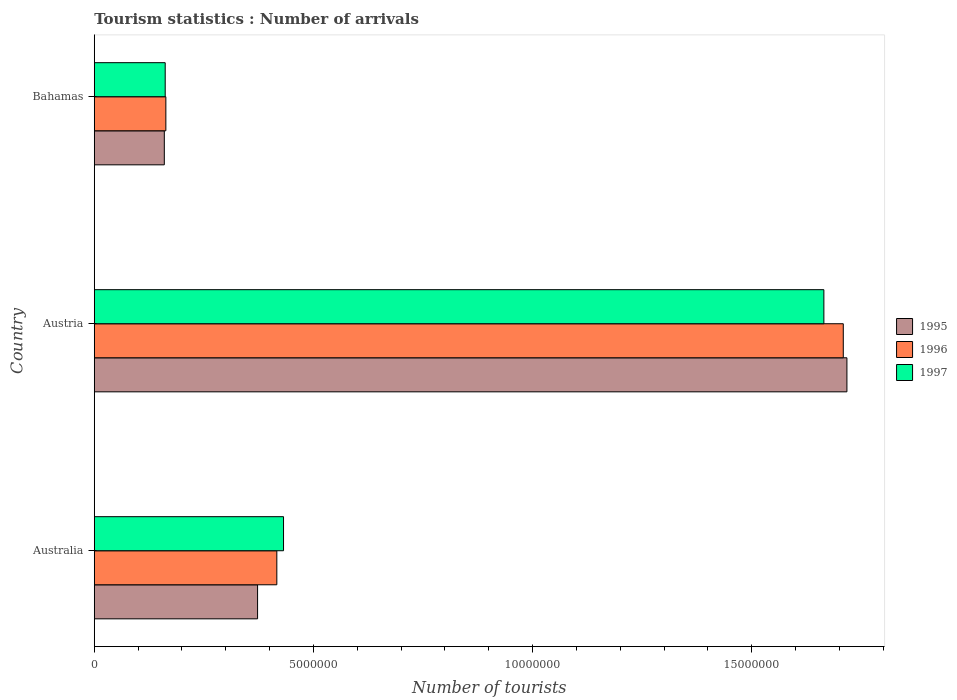Are the number of bars per tick equal to the number of legend labels?
Your answer should be very brief. Yes. Are the number of bars on each tick of the Y-axis equal?
Provide a short and direct response. Yes. How many bars are there on the 1st tick from the top?
Give a very brief answer. 3. How many bars are there on the 3rd tick from the bottom?
Keep it short and to the point. 3. In how many cases, is the number of bars for a given country not equal to the number of legend labels?
Provide a short and direct response. 0. What is the number of tourist arrivals in 1995 in Bahamas?
Your answer should be very brief. 1.60e+06. Across all countries, what is the maximum number of tourist arrivals in 1996?
Make the answer very short. 1.71e+07. Across all countries, what is the minimum number of tourist arrivals in 1995?
Your answer should be compact. 1.60e+06. In which country was the number of tourist arrivals in 1997 maximum?
Your answer should be very brief. Austria. In which country was the number of tourist arrivals in 1996 minimum?
Your response must be concise. Bahamas. What is the total number of tourist arrivals in 1996 in the graph?
Keep it short and to the point. 2.29e+07. What is the difference between the number of tourist arrivals in 1997 in Australia and that in Austria?
Keep it short and to the point. -1.23e+07. What is the difference between the number of tourist arrivals in 1996 in Bahamas and the number of tourist arrivals in 1995 in Australia?
Offer a very short reply. -2.09e+06. What is the average number of tourist arrivals in 1995 per country?
Offer a very short reply. 7.50e+06. What is the difference between the number of tourist arrivals in 1997 and number of tourist arrivals in 1996 in Australia?
Provide a succinct answer. 1.53e+05. What is the ratio of the number of tourist arrivals in 1996 in Austria to that in Bahamas?
Offer a terse response. 10.47. Is the number of tourist arrivals in 1995 in Australia less than that in Austria?
Your answer should be very brief. Yes. Is the difference between the number of tourist arrivals in 1997 in Australia and Austria greater than the difference between the number of tourist arrivals in 1996 in Australia and Austria?
Provide a succinct answer. Yes. What is the difference between the highest and the second highest number of tourist arrivals in 1997?
Your response must be concise. 1.23e+07. What is the difference between the highest and the lowest number of tourist arrivals in 1996?
Provide a short and direct response. 1.55e+07. In how many countries, is the number of tourist arrivals in 1995 greater than the average number of tourist arrivals in 1995 taken over all countries?
Give a very brief answer. 1. Is the sum of the number of tourist arrivals in 1995 in Australia and Austria greater than the maximum number of tourist arrivals in 1996 across all countries?
Offer a very short reply. Yes. Is it the case that in every country, the sum of the number of tourist arrivals in 1995 and number of tourist arrivals in 1997 is greater than the number of tourist arrivals in 1996?
Ensure brevity in your answer.  Yes. How many bars are there?
Give a very brief answer. 9. What is the difference between two consecutive major ticks on the X-axis?
Keep it short and to the point. 5.00e+06. Does the graph contain grids?
Keep it short and to the point. No. How many legend labels are there?
Your response must be concise. 3. What is the title of the graph?
Ensure brevity in your answer.  Tourism statistics : Number of arrivals. Does "1967" appear as one of the legend labels in the graph?
Make the answer very short. No. What is the label or title of the X-axis?
Your answer should be very brief. Number of tourists. What is the label or title of the Y-axis?
Offer a terse response. Country. What is the Number of tourists in 1995 in Australia?
Keep it short and to the point. 3.73e+06. What is the Number of tourists of 1996 in Australia?
Keep it short and to the point. 4.16e+06. What is the Number of tourists in 1997 in Australia?
Ensure brevity in your answer.  4.32e+06. What is the Number of tourists of 1995 in Austria?
Make the answer very short. 1.72e+07. What is the Number of tourists in 1996 in Austria?
Make the answer very short. 1.71e+07. What is the Number of tourists in 1997 in Austria?
Offer a terse response. 1.66e+07. What is the Number of tourists in 1995 in Bahamas?
Your answer should be very brief. 1.60e+06. What is the Number of tourists in 1996 in Bahamas?
Offer a very short reply. 1.63e+06. What is the Number of tourists of 1997 in Bahamas?
Your response must be concise. 1.62e+06. Across all countries, what is the maximum Number of tourists of 1995?
Give a very brief answer. 1.72e+07. Across all countries, what is the maximum Number of tourists of 1996?
Provide a short and direct response. 1.71e+07. Across all countries, what is the maximum Number of tourists of 1997?
Keep it short and to the point. 1.66e+07. Across all countries, what is the minimum Number of tourists of 1995?
Keep it short and to the point. 1.60e+06. Across all countries, what is the minimum Number of tourists of 1996?
Ensure brevity in your answer.  1.63e+06. Across all countries, what is the minimum Number of tourists of 1997?
Ensure brevity in your answer.  1.62e+06. What is the total Number of tourists of 1995 in the graph?
Provide a succinct answer. 2.25e+07. What is the total Number of tourists of 1996 in the graph?
Provide a short and direct response. 2.29e+07. What is the total Number of tourists in 1997 in the graph?
Provide a short and direct response. 2.26e+07. What is the difference between the Number of tourists of 1995 in Australia and that in Austria?
Offer a terse response. -1.34e+07. What is the difference between the Number of tourists of 1996 in Australia and that in Austria?
Your answer should be very brief. -1.29e+07. What is the difference between the Number of tourists in 1997 in Australia and that in Austria?
Ensure brevity in your answer.  -1.23e+07. What is the difference between the Number of tourists in 1995 in Australia and that in Bahamas?
Your answer should be very brief. 2.13e+06. What is the difference between the Number of tourists in 1996 in Australia and that in Bahamas?
Offer a very short reply. 2.53e+06. What is the difference between the Number of tourists of 1997 in Australia and that in Bahamas?
Ensure brevity in your answer.  2.70e+06. What is the difference between the Number of tourists in 1995 in Austria and that in Bahamas?
Give a very brief answer. 1.56e+07. What is the difference between the Number of tourists of 1996 in Austria and that in Bahamas?
Keep it short and to the point. 1.55e+07. What is the difference between the Number of tourists of 1997 in Austria and that in Bahamas?
Your answer should be very brief. 1.50e+07. What is the difference between the Number of tourists in 1995 in Australia and the Number of tourists in 1996 in Austria?
Offer a very short reply. -1.34e+07. What is the difference between the Number of tourists in 1995 in Australia and the Number of tourists in 1997 in Austria?
Your response must be concise. -1.29e+07. What is the difference between the Number of tourists of 1996 in Australia and the Number of tourists of 1997 in Austria?
Offer a terse response. -1.25e+07. What is the difference between the Number of tourists of 1995 in Australia and the Number of tourists of 1996 in Bahamas?
Your answer should be compact. 2.09e+06. What is the difference between the Number of tourists in 1995 in Australia and the Number of tourists in 1997 in Bahamas?
Provide a short and direct response. 2.11e+06. What is the difference between the Number of tourists of 1996 in Australia and the Number of tourists of 1997 in Bahamas?
Your response must be concise. 2.55e+06. What is the difference between the Number of tourists in 1995 in Austria and the Number of tourists in 1996 in Bahamas?
Your answer should be very brief. 1.55e+07. What is the difference between the Number of tourists in 1995 in Austria and the Number of tourists in 1997 in Bahamas?
Provide a succinct answer. 1.56e+07. What is the difference between the Number of tourists of 1996 in Austria and the Number of tourists of 1997 in Bahamas?
Provide a succinct answer. 1.55e+07. What is the average Number of tourists of 1995 per country?
Your answer should be compact. 7.50e+06. What is the average Number of tourists of 1996 per country?
Keep it short and to the point. 7.63e+06. What is the average Number of tourists in 1997 per country?
Provide a succinct answer. 7.53e+06. What is the difference between the Number of tourists in 1995 and Number of tourists in 1996 in Australia?
Make the answer very short. -4.39e+05. What is the difference between the Number of tourists in 1995 and Number of tourists in 1997 in Australia?
Provide a succinct answer. -5.92e+05. What is the difference between the Number of tourists in 1996 and Number of tourists in 1997 in Australia?
Make the answer very short. -1.53e+05. What is the difference between the Number of tourists of 1995 and Number of tourists of 1996 in Austria?
Provide a short and direct response. 8.30e+04. What is the difference between the Number of tourists of 1995 and Number of tourists of 1997 in Austria?
Give a very brief answer. 5.26e+05. What is the difference between the Number of tourists of 1996 and Number of tourists of 1997 in Austria?
Ensure brevity in your answer.  4.43e+05. What is the difference between the Number of tourists in 1995 and Number of tourists in 1996 in Bahamas?
Give a very brief answer. -3.50e+04. What is the difference between the Number of tourists in 1996 and Number of tourists in 1997 in Bahamas?
Your response must be concise. 1.50e+04. What is the ratio of the Number of tourists in 1995 in Australia to that in Austria?
Provide a short and direct response. 0.22. What is the ratio of the Number of tourists of 1996 in Australia to that in Austria?
Make the answer very short. 0.24. What is the ratio of the Number of tourists in 1997 in Australia to that in Austria?
Your answer should be very brief. 0.26. What is the ratio of the Number of tourists of 1995 in Australia to that in Bahamas?
Keep it short and to the point. 2.33. What is the ratio of the Number of tourists in 1996 in Australia to that in Bahamas?
Keep it short and to the point. 2.55. What is the ratio of the Number of tourists of 1997 in Australia to that in Bahamas?
Your answer should be compact. 2.67. What is the ratio of the Number of tourists in 1995 in Austria to that in Bahamas?
Offer a very short reply. 10.75. What is the ratio of the Number of tourists of 1996 in Austria to that in Bahamas?
Your response must be concise. 10.47. What is the ratio of the Number of tourists of 1997 in Austria to that in Bahamas?
Keep it short and to the point. 10.29. What is the difference between the highest and the second highest Number of tourists in 1995?
Offer a terse response. 1.34e+07. What is the difference between the highest and the second highest Number of tourists in 1996?
Your answer should be very brief. 1.29e+07. What is the difference between the highest and the second highest Number of tourists in 1997?
Provide a short and direct response. 1.23e+07. What is the difference between the highest and the lowest Number of tourists of 1995?
Ensure brevity in your answer.  1.56e+07. What is the difference between the highest and the lowest Number of tourists of 1996?
Offer a very short reply. 1.55e+07. What is the difference between the highest and the lowest Number of tourists of 1997?
Your answer should be very brief. 1.50e+07. 